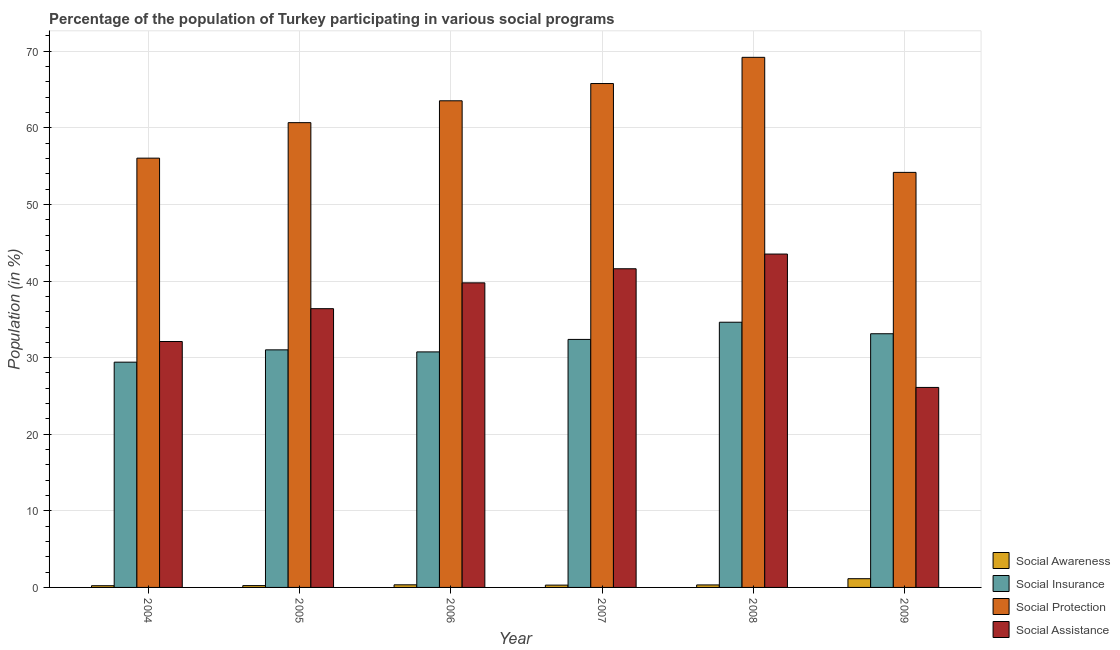Are the number of bars per tick equal to the number of legend labels?
Make the answer very short. Yes. Are the number of bars on each tick of the X-axis equal?
Provide a succinct answer. Yes. How many bars are there on the 6th tick from the left?
Keep it short and to the point. 4. How many bars are there on the 4th tick from the right?
Offer a terse response. 4. What is the label of the 3rd group of bars from the left?
Give a very brief answer. 2006. In how many cases, is the number of bars for a given year not equal to the number of legend labels?
Give a very brief answer. 0. What is the participation of population in social awareness programs in 2005?
Your answer should be compact. 0.24. Across all years, what is the maximum participation of population in social protection programs?
Offer a very short reply. 69.21. Across all years, what is the minimum participation of population in social protection programs?
Offer a very short reply. 54.19. In which year was the participation of population in social insurance programs maximum?
Provide a short and direct response. 2008. In which year was the participation of population in social assistance programs minimum?
Your answer should be compact. 2009. What is the total participation of population in social assistance programs in the graph?
Ensure brevity in your answer.  219.5. What is the difference between the participation of population in social awareness programs in 2007 and that in 2009?
Give a very brief answer. -0.84. What is the difference between the participation of population in social insurance programs in 2009 and the participation of population in social awareness programs in 2007?
Offer a very short reply. 0.74. What is the average participation of population in social assistance programs per year?
Provide a succinct answer. 36.58. In the year 2009, what is the difference between the participation of population in social assistance programs and participation of population in social awareness programs?
Offer a terse response. 0. What is the ratio of the participation of population in social assistance programs in 2005 to that in 2007?
Your response must be concise. 0.87. Is the participation of population in social insurance programs in 2005 less than that in 2006?
Ensure brevity in your answer.  No. What is the difference between the highest and the second highest participation of population in social insurance programs?
Give a very brief answer. 1.5. What is the difference between the highest and the lowest participation of population in social insurance programs?
Ensure brevity in your answer.  5.21. In how many years, is the participation of population in social protection programs greater than the average participation of population in social protection programs taken over all years?
Give a very brief answer. 3. Is the sum of the participation of population in social awareness programs in 2004 and 2007 greater than the maximum participation of population in social assistance programs across all years?
Ensure brevity in your answer.  No. Is it the case that in every year, the sum of the participation of population in social awareness programs and participation of population in social assistance programs is greater than the sum of participation of population in social insurance programs and participation of population in social protection programs?
Provide a short and direct response. No. What does the 2nd bar from the left in 2005 represents?
Offer a very short reply. Social Insurance. What does the 2nd bar from the right in 2005 represents?
Give a very brief answer. Social Protection. Is it the case that in every year, the sum of the participation of population in social awareness programs and participation of population in social insurance programs is greater than the participation of population in social protection programs?
Ensure brevity in your answer.  No. How many bars are there?
Make the answer very short. 24. What is the difference between two consecutive major ticks on the Y-axis?
Provide a succinct answer. 10. Does the graph contain grids?
Your answer should be compact. Yes. Where does the legend appear in the graph?
Give a very brief answer. Bottom right. How many legend labels are there?
Your response must be concise. 4. What is the title of the graph?
Your answer should be compact. Percentage of the population of Turkey participating in various social programs . Does "PFC gas" appear as one of the legend labels in the graph?
Make the answer very short. No. What is the label or title of the X-axis?
Your answer should be compact. Year. What is the Population (in %) of Social Awareness in 2004?
Provide a short and direct response. 0.22. What is the Population (in %) in Social Insurance in 2004?
Your response must be concise. 29.41. What is the Population (in %) in Social Protection in 2004?
Give a very brief answer. 56.05. What is the Population (in %) in Social Assistance in 2004?
Your answer should be compact. 32.11. What is the Population (in %) in Social Awareness in 2005?
Provide a succinct answer. 0.24. What is the Population (in %) in Social Insurance in 2005?
Ensure brevity in your answer.  31.02. What is the Population (in %) in Social Protection in 2005?
Provide a short and direct response. 60.68. What is the Population (in %) in Social Assistance in 2005?
Provide a succinct answer. 36.39. What is the Population (in %) in Social Awareness in 2006?
Keep it short and to the point. 0.34. What is the Population (in %) in Social Insurance in 2006?
Offer a very short reply. 30.75. What is the Population (in %) in Social Protection in 2006?
Your answer should be compact. 63.53. What is the Population (in %) in Social Assistance in 2006?
Keep it short and to the point. 39.76. What is the Population (in %) of Social Awareness in 2007?
Provide a succinct answer. 0.3. What is the Population (in %) of Social Insurance in 2007?
Your response must be concise. 32.38. What is the Population (in %) in Social Protection in 2007?
Your answer should be very brief. 65.79. What is the Population (in %) of Social Assistance in 2007?
Provide a short and direct response. 41.61. What is the Population (in %) in Social Awareness in 2008?
Keep it short and to the point. 0.33. What is the Population (in %) of Social Insurance in 2008?
Offer a terse response. 34.62. What is the Population (in %) in Social Protection in 2008?
Offer a very short reply. 69.21. What is the Population (in %) of Social Assistance in 2008?
Offer a very short reply. 43.52. What is the Population (in %) in Social Awareness in 2009?
Keep it short and to the point. 1.14. What is the Population (in %) of Social Insurance in 2009?
Provide a succinct answer. 33.12. What is the Population (in %) in Social Protection in 2009?
Your answer should be very brief. 54.19. What is the Population (in %) of Social Assistance in 2009?
Ensure brevity in your answer.  26.11. Across all years, what is the maximum Population (in %) of Social Awareness?
Provide a succinct answer. 1.14. Across all years, what is the maximum Population (in %) of Social Insurance?
Provide a short and direct response. 34.62. Across all years, what is the maximum Population (in %) in Social Protection?
Give a very brief answer. 69.21. Across all years, what is the maximum Population (in %) in Social Assistance?
Offer a very short reply. 43.52. Across all years, what is the minimum Population (in %) in Social Awareness?
Ensure brevity in your answer.  0.22. Across all years, what is the minimum Population (in %) in Social Insurance?
Keep it short and to the point. 29.41. Across all years, what is the minimum Population (in %) of Social Protection?
Your response must be concise. 54.19. Across all years, what is the minimum Population (in %) in Social Assistance?
Offer a very short reply. 26.11. What is the total Population (in %) in Social Awareness in the graph?
Give a very brief answer. 2.57. What is the total Population (in %) of Social Insurance in the graph?
Provide a succinct answer. 191.3. What is the total Population (in %) in Social Protection in the graph?
Keep it short and to the point. 369.44. What is the total Population (in %) of Social Assistance in the graph?
Make the answer very short. 219.5. What is the difference between the Population (in %) in Social Awareness in 2004 and that in 2005?
Provide a succinct answer. -0.02. What is the difference between the Population (in %) in Social Insurance in 2004 and that in 2005?
Keep it short and to the point. -1.61. What is the difference between the Population (in %) in Social Protection in 2004 and that in 2005?
Your response must be concise. -4.63. What is the difference between the Population (in %) in Social Assistance in 2004 and that in 2005?
Provide a short and direct response. -4.29. What is the difference between the Population (in %) of Social Awareness in 2004 and that in 2006?
Ensure brevity in your answer.  -0.12. What is the difference between the Population (in %) in Social Insurance in 2004 and that in 2006?
Keep it short and to the point. -1.34. What is the difference between the Population (in %) in Social Protection in 2004 and that in 2006?
Provide a succinct answer. -7.49. What is the difference between the Population (in %) of Social Assistance in 2004 and that in 2006?
Your answer should be very brief. -7.66. What is the difference between the Population (in %) of Social Awareness in 2004 and that in 2007?
Offer a very short reply. -0.08. What is the difference between the Population (in %) of Social Insurance in 2004 and that in 2007?
Keep it short and to the point. -2.97. What is the difference between the Population (in %) of Social Protection in 2004 and that in 2007?
Your answer should be compact. -9.74. What is the difference between the Population (in %) of Social Assistance in 2004 and that in 2007?
Give a very brief answer. -9.5. What is the difference between the Population (in %) of Social Awareness in 2004 and that in 2008?
Ensure brevity in your answer.  -0.1. What is the difference between the Population (in %) in Social Insurance in 2004 and that in 2008?
Offer a very short reply. -5.21. What is the difference between the Population (in %) of Social Protection in 2004 and that in 2008?
Ensure brevity in your answer.  -13.16. What is the difference between the Population (in %) in Social Assistance in 2004 and that in 2008?
Offer a very short reply. -11.42. What is the difference between the Population (in %) of Social Awareness in 2004 and that in 2009?
Your answer should be compact. -0.92. What is the difference between the Population (in %) of Social Insurance in 2004 and that in 2009?
Your answer should be compact. -3.71. What is the difference between the Population (in %) in Social Protection in 2004 and that in 2009?
Provide a succinct answer. 1.86. What is the difference between the Population (in %) in Social Assistance in 2004 and that in 2009?
Offer a very short reply. 6. What is the difference between the Population (in %) in Social Awareness in 2005 and that in 2006?
Ensure brevity in your answer.  -0.1. What is the difference between the Population (in %) of Social Insurance in 2005 and that in 2006?
Your answer should be compact. 0.27. What is the difference between the Population (in %) in Social Protection in 2005 and that in 2006?
Your answer should be very brief. -2.86. What is the difference between the Population (in %) in Social Assistance in 2005 and that in 2006?
Your answer should be compact. -3.37. What is the difference between the Population (in %) of Social Awareness in 2005 and that in 2007?
Your answer should be compact. -0.06. What is the difference between the Population (in %) of Social Insurance in 2005 and that in 2007?
Your response must be concise. -1.36. What is the difference between the Population (in %) in Social Protection in 2005 and that in 2007?
Your response must be concise. -5.11. What is the difference between the Population (in %) in Social Assistance in 2005 and that in 2007?
Ensure brevity in your answer.  -5.21. What is the difference between the Population (in %) in Social Awareness in 2005 and that in 2008?
Give a very brief answer. -0.09. What is the difference between the Population (in %) of Social Insurance in 2005 and that in 2008?
Your response must be concise. -3.61. What is the difference between the Population (in %) of Social Protection in 2005 and that in 2008?
Offer a terse response. -8.53. What is the difference between the Population (in %) in Social Assistance in 2005 and that in 2008?
Offer a very short reply. -7.13. What is the difference between the Population (in %) of Social Awareness in 2005 and that in 2009?
Your answer should be very brief. -0.9. What is the difference between the Population (in %) of Social Insurance in 2005 and that in 2009?
Your response must be concise. -2.1. What is the difference between the Population (in %) of Social Protection in 2005 and that in 2009?
Your answer should be compact. 6.49. What is the difference between the Population (in %) in Social Assistance in 2005 and that in 2009?
Give a very brief answer. 10.28. What is the difference between the Population (in %) in Social Awareness in 2006 and that in 2007?
Offer a terse response. 0.04. What is the difference between the Population (in %) in Social Insurance in 2006 and that in 2007?
Provide a short and direct response. -1.63. What is the difference between the Population (in %) in Social Protection in 2006 and that in 2007?
Your answer should be very brief. -2.25. What is the difference between the Population (in %) in Social Assistance in 2006 and that in 2007?
Give a very brief answer. -1.84. What is the difference between the Population (in %) in Social Awareness in 2006 and that in 2008?
Provide a short and direct response. 0.01. What is the difference between the Population (in %) of Social Insurance in 2006 and that in 2008?
Offer a terse response. -3.87. What is the difference between the Population (in %) in Social Protection in 2006 and that in 2008?
Provide a short and direct response. -5.67. What is the difference between the Population (in %) in Social Assistance in 2006 and that in 2008?
Your answer should be very brief. -3.76. What is the difference between the Population (in %) in Social Awareness in 2006 and that in 2009?
Your answer should be very brief. -0.8. What is the difference between the Population (in %) of Social Insurance in 2006 and that in 2009?
Make the answer very short. -2.37. What is the difference between the Population (in %) of Social Protection in 2006 and that in 2009?
Your response must be concise. 9.35. What is the difference between the Population (in %) of Social Assistance in 2006 and that in 2009?
Ensure brevity in your answer.  13.65. What is the difference between the Population (in %) in Social Awareness in 2007 and that in 2008?
Make the answer very short. -0.03. What is the difference between the Population (in %) of Social Insurance in 2007 and that in 2008?
Your answer should be very brief. -2.24. What is the difference between the Population (in %) of Social Protection in 2007 and that in 2008?
Provide a succinct answer. -3.42. What is the difference between the Population (in %) in Social Assistance in 2007 and that in 2008?
Offer a very short reply. -1.92. What is the difference between the Population (in %) of Social Awareness in 2007 and that in 2009?
Your answer should be very brief. -0.84. What is the difference between the Population (in %) in Social Insurance in 2007 and that in 2009?
Provide a short and direct response. -0.74. What is the difference between the Population (in %) of Social Protection in 2007 and that in 2009?
Offer a very short reply. 11.6. What is the difference between the Population (in %) of Social Assistance in 2007 and that in 2009?
Make the answer very short. 15.49. What is the difference between the Population (in %) of Social Awareness in 2008 and that in 2009?
Provide a succinct answer. -0.81. What is the difference between the Population (in %) of Social Insurance in 2008 and that in 2009?
Your answer should be compact. 1.5. What is the difference between the Population (in %) in Social Protection in 2008 and that in 2009?
Provide a succinct answer. 15.02. What is the difference between the Population (in %) in Social Assistance in 2008 and that in 2009?
Provide a succinct answer. 17.41. What is the difference between the Population (in %) in Social Awareness in 2004 and the Population (in %) in Social Insurance in 2005?
Ensure brevity in your answer.  -30.79. What is the difference between the Population (in %) in Social Awareness in 2004 and the Population (in %) in Social Protection in 2005?
Your answer should be very brief. -60.46. What is the difference between the Population (in %) in Social Awareness in 2004 and the Population (in %) in Social Assistance in 2005?
Offer a terse response. -36.17. What is the difference between the Population (in %) in Social Insurance in 2004 and the Population (in %) in Social Protection in 2005?
Make the answer very short. -31.27. What is the difference between the Population (in %) of Social Insurance in 2004 and the Population (in %) of Social Assistance in 2005?
Your answer should be very brief. -6.98. What is the difference between the Population (in %) of Social Protection in 2004 and the Population (in %) of Social Assistance in 2005?
Keep it short and to the point. 19.65. What is the difference between the Population (in %) in Social Awareness in 2004 and the Population (in %) in Social Insurance in 2006?
Provide a short and direct response. -30.53. What is the difference between the Population (in %) in Social Awareness in 2004 and the Population (in %) in Social Protection in 2006?
Provide a succinct answer. -63.31. What is the difference between the Population (in %) in Social Awareness in 2004 and the Population (in %) in Social Assistance in 2006?
Keep it short and to the point. -39.54. What is the difference between the Population (in %) in Social Insurance in 2004 and the Population (in %) in Social Protection in 2006?
Provide a succinct answer. -34.12. What is the difference between the Population (in %) in Social Insurance in 2004 and the Population (in %) in Social Assistance in 2006?
Offer a very short reply. -10.35. What is the difference between the Population (in %) in Social Protection in 2004 and the Population (in %) in Social Assistance in 2006?
Offer a terse response. 16.28. What is the difference between the Population (in %) in Social Awareness in 2004 and the Population (in %) in Social Insurance in 2007?
Offer a terse response. -32.16. What is the difference between the Population (in %) of Social Awareness in 2004 and the Population (in %) of Social Protection in 2007?
Give a very brief answer. -65.56. What is the difference between the Population (in %) in Social Awareness in 2004 and the Population (in %) in Social Assistance in 2007?
Your answer should be compact. -41.38. What is the difference between the Population (in %) of Social Insurance in 2004 and the Population (in %) of Social Protection in 2007?
Provide a short and direct response. -36.38. What is the difference between the Population (in %) of Social Insurance in 2004 and the Population (in %) of Social Assistance in 2007?
Make the answer very short. -12.19. What is the difference between the Population (in %) of Social Protection in 2004 and the Population (in %) of Social Assistance in 2007?
Your answer should be compact. 14.44. What is the difference between the Population (in %) in Social Awareness in 2004 and the Population (in %) in Social Insurance in 2008?
Offer a terse response. -34.4. What is the difference between the Population (in %) of Social Awareness in 2004 and the Population (in %) of Social Protection in 2008?
Your answer should be very brief. -68.98. What is the difference between the Population (in %) of Social Awareness in 2004 and the Population (in %) of Social Assistance in 2008?
Your response must be concise. -43.3. What is the difference between the Population (in %) in Social Insurance in 2004 and the Population (in %) in Social Protection in 2008?
Your answer should be compact. -39.8. What is the difference between the Population (in %) in Social Insurance in 2004 and the Population (in %) in Social Assistance in 2008?
Keep it short and to the point. -14.11. What is the difference between the Population (in %) of Social Protection in 2004 and the Population (in %) of Social Assistance in 2008?
Your answer should be compact. 12.52. What is the difference between the Population (in %) in Social Awareness in 2004 and the Population (in %) in Social Insurance in 2009?
Your response must be concise. -32.9. What is the difference between the Population (in %) in Social Awareness in 2004 and the Population (in %) in Social Protection in 2009?
Offer a very short reply. -53.96. What is the difference between the Population (in %) in Social Awareness in 2004 and the Population (in %) in Social Assistance in 2009?
Give a very brief answer. -25.89. What is the difference between the Population (in %) of Social Insurance in 2004 and the Population (in %) of Social Protection in 2009?
Provide a short and direct response. -24.78. What is the difference between the Population (in %) of Social Insurance in 2004 and the Population (in %) of Social Assistance in 2009?
Your answer should be compact. 3.3. What is the difference between the Population (in %) of Social Protection in 2004 and the Population (in %) of Social Assistance in 2009?
Provide a succinct answer. 29.93. What is the difference between the Population (in %) in Social Awareness in 2005 and the Population (in %) in Social Insurance in 2006?
Offer a terse response. -30.51. What is the difference between the Population (in %) of Social Awareness in 2005 and the Population (in %) of Social Protection in 2006?
Your response must be concise. -63.3. What is the difference between the Population (in %) in Social Awareness in 2005 and the Population (in %) in Social Assistance in 2006?
Make the answer very short. -39.53. What is the difference between the Population (in %) in Social Insurance in 2005 and the Population (in %) in Social Protection in 2006?
Offer a very short reply. -32.52. What is the difference between the Population (in %) of Social Insurance in 2005 and the Population (in %) of Social Assistance in 2006?
Make the answer very short. -8.75. What is the difference between the Population (in %) of Social Protection in 2005 and the Population (in %) of Social Assistance in 2006?
Ensure brevity in your answer.  20.91. What is the difference between the Population (in %) of Social Awareness in 2005 and the Population (in %) of Social Insurance in 2007?
Give a very brief answer. -32.14. What is the difference between the Population (in %) in Social Awareness in 2005 and the Population (in %) in Social Protection in 2007?
Provide a short and direct response. -65.55. What is the difference between the Population (in %) in Social Awareness in 2005 and the Population (in %) in Social Assistance in 2007?
Make the answer very short. -41.37. What is the difference between the Population (in %) in Social Insurance in 2005 and the Population (in %) in Social Protection in 2007?
Ensure brevity in your answer.  -34.77. What is the difference between the Population (in %) of Social Insurance in 2005 and the Population (in %) of Social Assistance in 2007?
Provide a short and direct response. -10.59. What is the difference between the Population (in %) in Social Protection in 2005 and the Population (in %) in Social Assistance in 2007?
Your answer should be compact. 19.07. What is the difference between the Population (in %) of Social Awareness in 2005 and the Population (in %) of Social Insurance in 2008?
Provide a short and direct response. -34.39. What is the difference between the Population (in %) of Social Awareness in 2005 and the Population (in %) of Social Protection in 2008?
Keep it short and to the point. -68.97. What is the difference between the Population (in %) in Social Awareness in 2005 and the Population (in %) in Social Assistance in 2008?
Provide a succinct answer. -43.28. What is the difference between the Population (in %) in Social Insurance in 2005 and the Population (in %) in Social Protection in 2008?
Your response must be concise. -38.19. What is the difference between the Population (in %) in Social Insurance in 2005 and the Population (in %) in Social Assistance in 2008?
Your response must be concise. -12.51. What is the difference between the Population (in %) in Social Protection in 2005 and the Population (in %) in Social Assistance in 2008?
Provide a succinct answer. 17.16. What is the difference between the Population (in %) in Social Awareness in 2005 and the Population (in %) in Social Insurance in 2009?
Your answer should be compact. -32.88. What is the difference between the Population (in %) of Social Awareness in 2005 and the Population (in %) of Social Protection in 2009?
Offer a very short reply. -53.95. What is the difference between the Population (in %) in Social Awareness in 2005 and the Population (in %) in Social Assistance in 2009?
Your response must be concise. -25.87. What is the difference between the Population (in %) in Social Insurance in 2005 and the Population (in %) in Social Protection in 2009?
Give a very brief answer. -23.17. What is the difference between the Population (in %) of Social Insurance in 2005 and the Population (in %) of Social Assistance in 2009?
Your answer should be compact. 4.91. What is the difference between the Population (in %) in Social Protection in 2005 and the Population (in %) in Social Assistance in 2009?
Your answer should be very brief. 34.57. What is the difference between the Population (in %) in Social Awareness in 2006 and the Population (in %) in Social Insurance in 2007?
Give a very brief answer. -32.04. What is the difference between the Population (in %) of Social Awareness in 2006 and the Population (in %) of Social Protection in 2007?
Your response must be concise. -65.45. What is the difference between the Population (in %) in Social Awareness in 2006 and the Population (in %) in Social Assistance in 2007?
Your answer should be very brief. -41.26. What is the difference between the Population (in %) of Social Insurance in 2006 and the Population (in %) of Social Protection in 2007?
Give a very brief answer. -35.04. What is the difference between the Population (in %) in Social Insurance in 2006 and the Population (in %) in Social Assistance in 2007?
Provide a succinct answer. -10.86. What is the difference between the Population (in %) in Social Protection in 2006 and the Population (in %) in Social Assistance in 2007?
Offer a very short reply. 21.93. What is the difference between the Population (in %) of Social Awareness in 2006 and the Population (in %) of Social Insurance in 2008?
Make the answer very short. -34.28. What is the difference between the Population (in %) of Social Awareness in 2006 and the Population (in %) of Social Protection in 2008?
Provide a succinct answer. -68.87. What is the difference between the Population (in %) in Social Awareness in 2006 and the Population (in %) in Social Assistance in 2008?
Keep it short and to the point. -43.18. What is the difference between the Population (in %) of Social Insurance in 2006 and the Population (in %) of Social Protection in 2008?
Give a very brief answer. -38.46. What is the difference between the Population (in %) of Social Insurance in 2006 and the Population (in %) of Social Assistance in 2008?
Ensure brevity in your answer.  -12.77. What is the difference between the Population (in %) in Social Protection in 2006 and the Population (in %) in Social Assistance in 2008?
Give a very brief answer. 20.01. What is the difference between the Population (in %) in Social Awareness in 2006 and the Population (in %) in Social Insurance in 2009?
Make the answer very short. -32.78. What is the difference between the Population (in %) in Social Awareness in 2006 and the Population (in %) in Social Protection in 2009?
Offer a terse response. -53.85. What is the difference between the Population (in %) in Social Awareness in 2006 and the Population (in %) in Social Assistance in 2009?
Your answer should be very brief. -25.77. What is the difference between the Population (in %) of Social Insurance in 2006 and the Population (in %) of Social Protection in 2009?
Give a very brief answer. -23.44. What is the difference between the Population (in %) in Social Insurance in 2006 and the Population (in %) in Social Assistance in 2009?
Offer a very short reply. 4.64. What is the difference between the Population (in %) of Social Protection in 2006 and the Population (in %) of Social Assistance in 2009?
Offer a terse response. 37.42. What is the difference between the Population (in %) in Social Awareness in 2007 and the Population (in %) in Social Insurance in 2008?
Provide a succinct answer. -34.32. What is the difference between the Population (in %) in Social Awareness in 2007 and the Population (in %) in Social Protection in 2008?
Keep it short and to the point. -68.91. What is the difference between the Population (in %) in Social Awareness in 2007 and the Population (in %) in Social Assistance in 2008?
Your answer should be very brief. -43.22. What is the difference between the Population (in %) of Social Insurance in 2007 and the Population (in %) of Social Protection in 2008?
Your response must be concise. -36.83. What is the difference between the Population (in %) of Social Insurance in 2007 and the Population (in %) of Social Assistance in 2008?
Keep it short and to the point. -11.14. What is the difference between the Population (in %) in Social Protection in 2007 and the Population (in %) in Social Assistance in 2008?
Your answer should be very brief. 22.26. What is the difference between the Population (in %) of Social Awareness in 2007 and the Population (in %) of Social Insurance in 2009?
Give a very brief answer. -32.82. What is the difference between the Population (in %) in Social Awareness in 2007 and the Population (in %) in Social Protection in 2009?
Provide a succinct answer. -53.89. What is the difference between the Population (in %) in Social Awareness in 2007 and the Population (in %) in Social Assistance in 2009?
Give a very brief answer. -25.81. What is the difference between the Population (in %) in Social Insurance in 2007 and the Population (in %) in Social Protection in 2009?
Offer a terse response. -21.81. What is the difference between the Population (in %) in Social Insurance in 2007 and the Population (in %) in Social Assistance in 2009?
Offer a very short reply. 6.27. What is the difference between the Population (in %) in Social Protection in 2007 and the Population (in %) in Social Assistance in 2009?
Keep it short and to the point. 39.68. What is the difference between the Population (in %) of Social Awareness in 2008 and the Population (in %) of Social Insurance in 2009?
Offer a terse response. -32.79. What is the difference between the Population (in %) of Social Awareness in 2008 and the Population (in %) of Social Protection in 2009?
Your answer should be compact. -53.86. What is the difference between the Population (in %) in Social Awareness in 2008 and the Population (in %) in Social Assistance in 2009?
Provide a short and direct response. -25.78. What is the difference between the Population (in %) in Social Insurance in 2008 and the Population (in %) in Social Protection in 2009?
Make the answer very short. -19.56. What is the difference between the Population (in %) of Social Insurance in 2008 and the Population (in %) of Social Assistance in 2009?
Give a very brief answer. 8.51. What is the difference between the Population (in %) of Social Protection in 2008 and the Population (in %) of Social Assistance in 2009?
Offer a very short reply. 43.1. What is the average Population (in %) in Social Awareness per year?
Provide a short and direct response. 0.43. What is the average Population (in %) in Social Insurance per year?
Provide a succinct answer. 31.88. What is the average Population (in %) in Social Protection per year?
Provide a short and direct response. 61.57. What is the average Population (in %) in Social Assistance per year?
Make the answer very short. 36.58. In the year 2004, what is the difference between the Population (in %) of Social Awareness and Population (in %) of Social Insurance?
Give a very brief answer. -29.19. In the year 2004, what is the difference between the Population (in %) in Social Awareness and Population (in %) in Social Protection?
Keep it short and to the point. -55.82. In the year 2004, what is the difference between the Population (in %) of Social Awareness and Population (in %) of Social Assistance?
Make the answer very short. -31.88. In the year 2004, what is the difference between the Population (in %) of Social Insurance and Population (in %) of Social Protection?
Provide a succinct answer. -26.63. In the year 2004, what is the difference between the Population (in %) in Social Insurance and Population (in %) in Social Assistance?
Your answer should be very brief. -2.7. In the year 2004, what is the difference between the Population (in %) of Social Protection and Population (in %) of Social Assistance?
Your response must be concise. 23.94. In the year 2005, what is the difference between the Population (in %) in Social Awareness and Population (in %) in Social Insurance?
Your answer should be very brief. -30.78. In the year 2005, what is the difference between the Population (in %) in Social Awareness and Population (in %) in Social Protection?
Ensure brevity in your answer.  -60.44. In the year 2005, what is the difference between the Population (in %) in Social Awareness and Population (in %) in Social Assistance?
Offer a terse response. -36.15. In the year 2005, what is the difference between the Population (in %) of Social Insurance and Population (in %) of Social Protection?
Keep it short and to the point. -29.66. In the year 2005, what is the difference between the Population (in %) of Social Insurance and Population (in %) of Social Assistance?
Offer a very short reply. -5.38. In the year 2005, what is the difference between the Population (in %) of Social Protection and Population (in %) of Social Assistance?
Provide a short and direct response. 24.29. In the year 2006, what is the difference between the Population (in %) of Social Awareness and Population (in %) of Social Insurance?
Keep it short and to the point. -30.41. In the year 2006, what is the difference between the Population (in %) of Social Awareness and Population (in %) of Social Protection?
Provide a succinct answer. -63.19. In the year 2006, what is the difference between the Population (in %) of Social Awareness and Population (in %) of Social Assistance?
Your response must be concise. -39.42. In the year 2006, what is the difference between the Population (in %) in Social Insurance and Population (in %) in Social Protection?
Offer a very short reply. -32.78. In the year 2006, what is the difference between the Population (in %) of Social Insurance and Population (in %) of Social Assistance?
Offer a very short reply. -9.01. In the year 2006, what is the difference between the Population (in %) of Social Protection and Population (in %) of Social Assistance?
Provide a succinct answer. 23.77. In the year 2007, what is the difference between the Population (in %) in Social Awareness and Population (in %) in Social Insurance?
Your answer should be very brief. -32.08. In the year 2007, what is the difference between the Population (in %) in Social Awareness and Population (in %) in Social Protection?
Ensure brevity in your answer.  -65.49. In the year 2007, what is the difference between the Population (in %) in Social Awareness and Population (in %) in Social Assistance?
Give a very brief answer. -41.3. In the year 2007, what is the difference between the Population (in %) of Social Insurance and Population (in %) of Social Protection?
Provide a succinct answer. -33.41. In the year 2007, what is the difference between the Population (in %) of Social Insurance and Population (in %) of Social Assistance?
Your answer should be compact. -9.23. In the year 2007, what is the difference between the Population (in %) of Social Protection and Population (in %) of Social Assistance?
Keep it short and to the point. 24.18. In the year 2008, what is the difference between the Population (in %) of Social Awareness and Population (in %) of Social Insurance?
Your response must be concise. -34.3. In the year 2008, what is the difference between the Population (in %) of Social Awareness and Population (in %) of Social Protection?
Provide a succinct answer. -68.88. In the year 2008, what is the difference between the Population (in %) in Social Awareness and Population (in %) in Social Assistance?
Keep it short and to the point. -43.2. In the year 2008, what is the difference between the Population (in %) in Social Insurance and Population (in %) in Social Protection?
Keep it short and to the point. -34.58. In the year 2008, what is the difference between the Population (in %) in Social Insurance and Population (in %) in Social Assistance?
Make the answer very short. -8.9. In the year 2008, what is the difference between the Population (in %) of Social Protection and Population (in %) of Social Assistance?
Offer a very short reply. 25.68. In the year 2009, what is the difference between the Population (in %) in Social Awareness and Population (in %) in Social Insurance?
Offer a very short reply. -31.98. In the year 2009, what is the difference between the Population (in %) in Social Awareness and Population (in %) in Social Protection?
Make the answer very short. -53.05. In the year 2009, what is the difference between the Population (in %) in Social Awareness and Population (in %) in Social Assistance?
Offer a terse response. -24.97. In the year 2009, what is the difference between the Population (in %) in Social Insurance and Population (in %) in Social Protection?
Make the answer very short. -21.07. In the year 2009, what is the difference between the Population (in %) of Social Insurance and Population (in %) of Social Assistance?
Your response must be concise. 7.01. In the year 2009, what is the difference between the Population (in %) of Social Protection and Population (in %) of Social Assistance?
Your answer should be compact. 28.08. What is the ratio of the Population (in %) in Social Awareness in 2004 to that in 2005?
Provide a short and direct response. 0.94. What is the ratio of the Population (in %) of Social Insurance in 2004 to that in 2005?
Keep it short and to the point. 0.95. What is the ratio of the Population (in %) in Social Protection in 2004 to that in 2005?
Provide a short and direct response. 0.92. What is the ratio of the Population (in %) of Social Assistance in 2004 to that in 2005?
Make the answer very short. 0.88. What is the ratio of the Population (in %) in Social Awareness in 2004 to that in 2006?
Give a very brief answer. 0.65. What is the ratio of the Population (in %) in Social Insurance in 2004 to that in 2006?
Your answer should be compact. 0.96. What is the ratio of the Population (in %) in Social Protection in 2004 to that in 2006?
Your response must be concise. 0.88. What is the ratio of the Population (in %) of Social Assistance in 2004 to that in 2006?
Offer a very short reply. 0.81. What is the ratio of the Population (in %) of Social Awareness in 2004 to that in 2007?
Make the answer very short. 0.74. What is the ratio of the Population (in %) in Social Insurance in 2004 to that in 2007?
Give a very brief answer. 0.91. What is the ratio of the Population (in %) of Social Protection in 2004 to that in 2007?
Ensure brevity in your answer.  0.85. What is the ratio of the Population (in %) of Social Assistance in 2004 to that in 2007?
Provide a short and direct response. 0.77. What is the ratio of the Population (in %) of Social Awareness in 2004 to that in 2008?
Give a very brief answer. 0.68. What is the ratio of the Population (in %) of Social Insurance in 2004 to that in 2008?
Keep it short and to the point. 0.85. What is the ratio of the Population (in %) in Social Protection in 2004 to that in 2008?
Your answer should be very brief. 0.81. What is the ratio of the Population (in %) in Social Assistance in 2004 to that in 2008?
Offer a very short reply. 0.74. What is the ratio of the Population (in %) of Social Awareness in 2004 to that in 2009?
Provide a short and direct response. 0.2. What is the ratio of the Population (in %) of Social Insurance in 2004 to that in 2009?
Your answer should be compact. 0.89. What is the ratio of the Population (in %) of Social Protection in 2004 to that in 2009?
Ensure brevity in your answer.  1.03. What is the ratio of the Population (in %) of Social Assistance in 2004 to that in 2009?
Provide a succinct answer. 1.23. What is the ratio of the Population (in %) in Social Awareness in 2005 to that in 2006?
Offer a terse response. 0.7. What is the ratio of the Population (in %) in Social Insurance in 2005 to that in 2006?
Offer a very short reply. 1.01. What is the ratio of the Population (in %) in Social Protection in 2005 to that in 2006?
Make the answer very short. 0.96. What is the ratio of the Population (in %) of Social Assistance in 2005 to that in 2006?
Ensure brevity in your answer.  0.92. What is the ratio of the Population (in %) of Social Awareness in 2005 to that in 2007?
Provide a short and direct response. 0.79. What is the ratio of the Population (in %) of Social Insurance in 2005 to that in 2007?
Offer a very short reply. 0.96. What is the ratio of the Population (in %) of Social Protection in 2005 to that in 2007?
Make the answer very short. 0.92. What is the ratio of the Population (in %) in Social Assistance in 2005 to that in 2007?
Keep it short and to the point. 0.87. What is the ratio of the Population (in %) in Social Awareness in 2005 to that in 2008?
Your response must be concise. 0.73. What is the ratio of the Population (in %) in Social Insurance in 2005 to that in 2008?
Make the answer very short. 0.9. What is the ratio of the Population (in %) in Social Protection in 2005 to that in 2008?
Keep it short and to the point. 0.88. What is the ratio of the Population (in %) of Social Assistance in 2005 to that in 2008?
Ensure brevity in your answer.  0.84. What is the ratio of the Population (in %) in Social Awareness in 2005 to that in 2009?
Offer a terse response. 0.21. What is the ratio of the Population (in %) of Social Insurance in 2005 to that in 2009?
Give a very brief answer. 0.94. What is the ratio of the Population (in %) of Social Protection in 2005 to that in 2009?
Provide a succinct answer. 1.12. What is the ratio of the Population (in %) of Social Assistance in 2005 to that in 2009?
Provide a short and direct response. 1.39. What is the ratio of the Population (in %) of Social Awareness in 2006 to that in 2007?
Provide a short and direct response. 1.13. What is the ratio of the Population (in %) in Social Insurance in 2006 to that in 2007?
Keep it short and to the point. 0.95. What is the ratio of the Population (in %) of Social Protection in 2006 to that in 2007?
Keep it short and to the point. 0.97. What is the ratio of the Population (in %) in Social Assistance in 2006 to that in 2007?
Your answer should be very brief. 0.96. What is the ratio of the Population (in %) of Social Awareness in 2006 to that in 2008?
Keep it short and to the point. 1.04. What is the ratio of the Population (in %) of Social Insurance in 2006 to that in 2008?
Make the answer very short. 0.89. What is the ratio of the Population (in %) in Social Protection in 2006 to that in 2008?
Make the answer very short. 0.92. What is the ratio of the Population (in %) of Social Assistance in 2006 to that in 2008?
Offer a terse response. 0.91. What is the ratio of the Population (in %) of Social Awareness in 2006 to that in 2009?
Your answer should be very brief. 0.3. What is the ratio of the Population (in %) of Social Insurance in 2006 to that in 2009?
Offer a terse response. 0.93. What is the ratio of the Population (in %) in Social Protection in 2006 to that in 2009?
Your answer should be very brief. 1.17. What is the ratio of the Population (in %) of Social Assistance in 2006 to that in 2009?
Your response must be concise. 1.52. What is the ratio of the Population (in %) of Social Awareness in 2007 to that in 2008?
Your answer should be very brief. 0.92. What is the ratio of the Population (in %) of Social Insurance in 2007 to that in 2008?
Provide a succinct answer. 0.94. What is the ratio of the Population (in %) of Social Protection in 2007 to that in 2008?
Provide a short and direct response. 0.95. What is the ratio of the Population (in %) in Social Assistance in 2007 to that in 2008?
Offer a very short reply. 0.96. What is the ratio of the Population (in %) of Social Awareness in 2007 to that in 2009?
Provide a short and direct response. 0.26. What is the ratio of the Population (in %) of Social Insurance in 2007 to that in 2009?
Offer a very short reply. 0.98. What is the ratio of the Population (in %) in Social Protection in 2007 to that in 2009?
Give a very brief answer. 1.21. What is the ratio of the Population (in %) of Social Assistance in 2007 to that in 2009?
Offer a very short reply. 1.59. What is the ratio of the Population (in %) of Social Awareness in 2008 to that in 2009?
Make the answer very short. 0.29. What is the ratio of the Population (in %) of Social Insurance in 2008 to that in 2009?
Give a very brief answer. 1.05. What is the ratio of the Population (in %) in Social Protection in 2008 to that in 2009?
Provide a short and direct response. 1.28. What is the ratio of the Population (in %) in Social Assistance in 2008 to that in 2009?
Provide a succinct answer. 1.67. What is the difference between the highest and the second highest Population (in %) in Social Awareness?
Make the answer very short. 0.8. What is the difference between the highest and the second highest Population (in %) in Social Insurance?
Your response must be concise. 1.5. What is the difference between the highest and the second highest Population (in %) in Social Protection?
Ensure brevity in your answer.  3.42. What is the difference between the highest and the second highest Population (in %) in Social Assistance?
Your response must be concise. 1.92. What is the difference between the highest and the lowest Population (in %) of Social Awareness?
Offer a very short reply. 0.92. What is the difference between the highest and the lowest Population (in %) of Social Insurance?
Provide a succinct answer. 5.21. What is the difference between the highest and the lowest Population (in %) in Social Protection?
Ensure brevity in your answer.  15.02. What is the difference between the highest and the lowest Population (in %) in Social Assistance?
Ensure brevity in your answer.  17.41. 